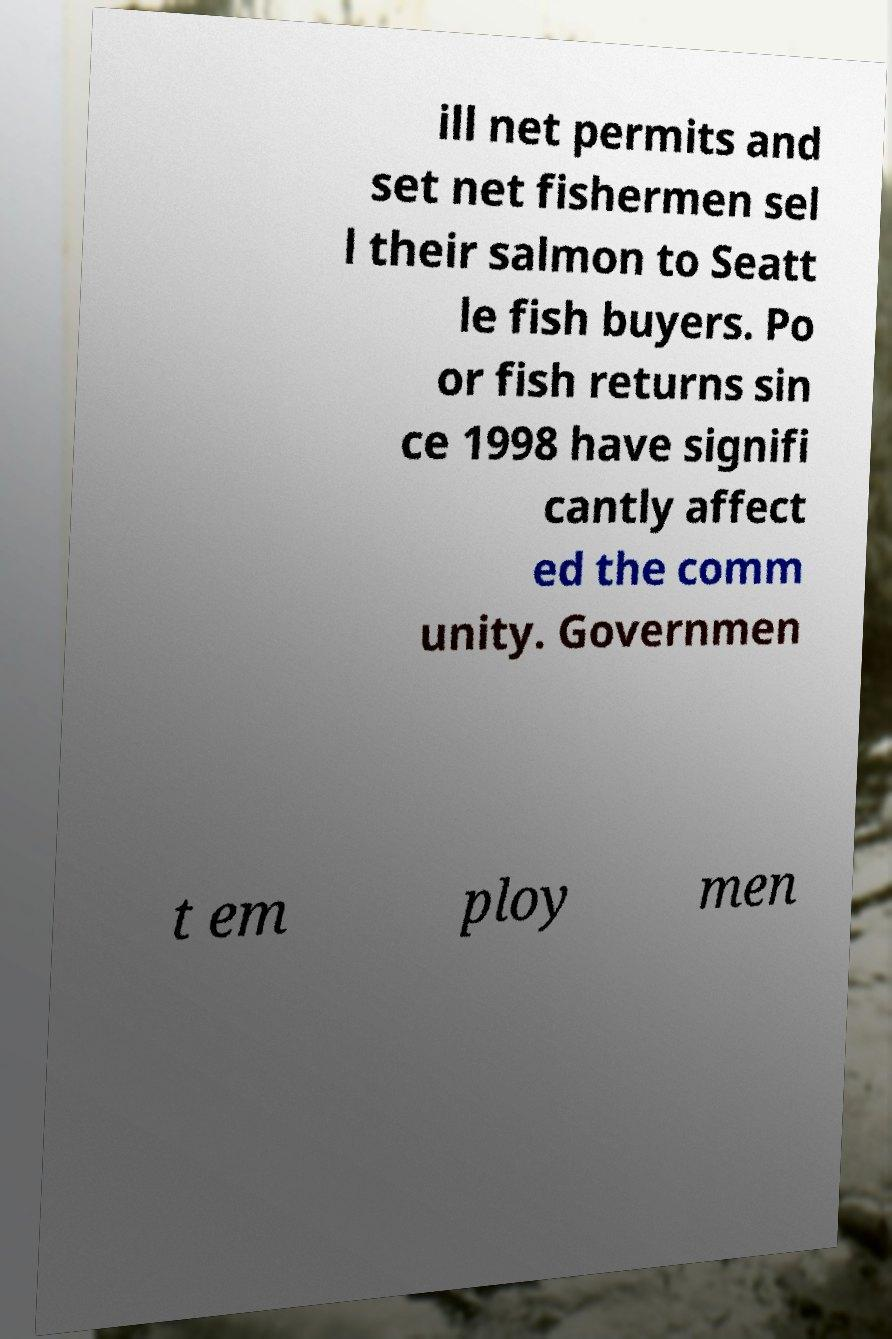I need the written content from this picture converted into text. Can you do that? ill net permits and set net fishermen sel l their salmon to Seatt le fish buyers. Po or fish returns sin ce 1998 have signifi cantly affect ed the comm unity. Governmen t em ploy men 